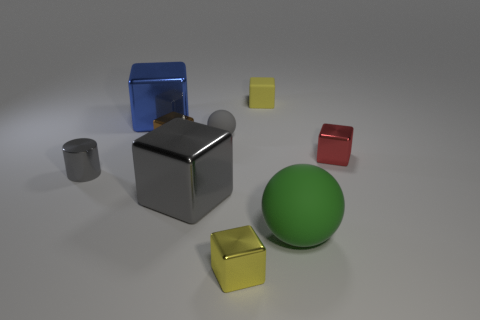What number of other cubes are made of the same material as the big blue block?
Your answer should be very brief. 4. Is the number of tiny red blocks that are left of the blue object less than the number of big spheres behind the brown metal cube?
Offer a very short reply. No. What material is the big block that is behind the gray metal object that is to the right of the large object behind the tiny brown metallic cube?
Offer a terse response. Metal. How big is the object that is both in front of the gray metallic block and behind the tiny yellow metallic thing?
Your response must be concise. Large. What number of balls are either brown metal objects or small red things?
Offer a terse response. 0. What is the color of the rubber block that is the same size as the red metal thing?
Make the answer very short. Yellow. Are there any other things that have the same shape as the red object?
Make the answer very short. Yes. The other big shiny thing that is the same shape as the blue shiny thing is what color?
Your answer should be very brief. Gray. How many things are large brown cylinders or small cubes in front of the small yellow matte object?
Make the answer very short. 3. Are there fewer small objects that are behind the large matte object than small matte spheres?
Your answer should be very brief. No. 